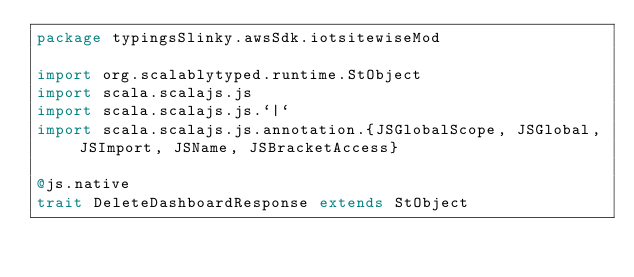<code> <loc_0><loc_0><loc_500><loc_500><_Scala_>package typingsSlinky.awsSdk.iotsitewiseMod

import org.scalablytyped.runtime.StObject
import scala.scalajs.js
import scala.scalajs.js.`|`
import scala.scalajs.js.annotation.{JSGlobalScope, JSGlobal, JSImport, JSName, JSBracketAccess}

@js.native
trait DeleteDashboardResponse extends StObject
</code> 